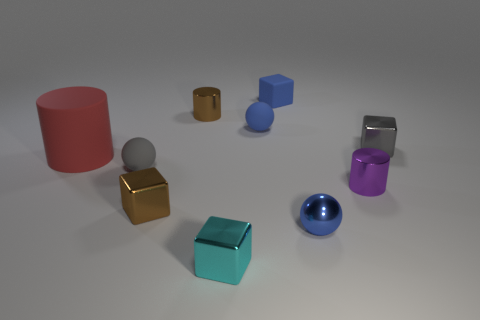The big rubber cylinder has what color?
Keep it short and to the point. Red. What number of small objects are either purple metallic things or yellow matte objects?
Your response must be concise. 1. Does the brown shiny block that is on the right side of the large red rubber cylinder have the same size as the red cylinder that is to the left of the small cyan metal thing?
Your answer should be compact. No. There is a brown thing that is the same shape as the large red thing; what size is it?
Keep it short and to the point. Small. Is the number of tiny cyan metal blocks that are behind the large cylinder greater than the number of gray rubber objects that are behind the small gray metallic thing?
Offer a very short reply. No. What is the cube that is both behind the small brown cube and left of the small blue metallic object made of?
Keep it short and to the point. Rubber. What is the color of the other rubber thing that is the same shape as the small gray matte thing?
Ensure brevity in your answer.  Blue. The red matte cylinder has what size?
Provide a succinct answer. Large. The tiny metallic cylinder right of the matte thing that is behind the brown cylinder is what color?
Keep it short and to the point. Purple. How many tiny cubes are both on the right side of the small blue rubber sphere and in front of the blue cube?
Your answer should be very brief. 1. 